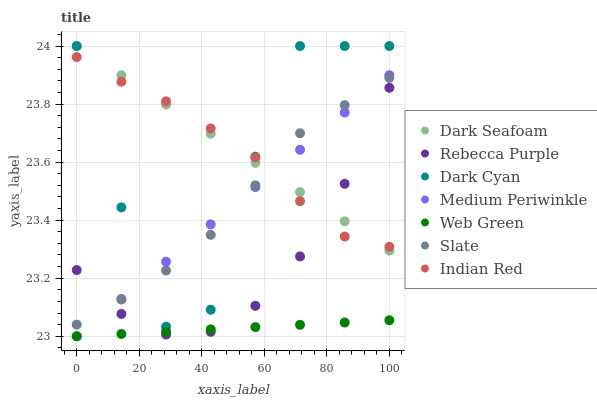Does Web Green have the minimum area under the curve?
Answer yes or no. Yes. Does Dark Seafoam have the maximum area under the curve?
Answer yes or no. Yes. Does Medium Periwinkle have the minimum area under the curve?
Answer yes or no. No. Does Medium Periwinkle have the maximum area under the curve?
Answer yes or no. No. Is Dark Seafoam the smoothest?
Answer yes or no. Yes. Is Dark Cyan the roughest?
Answer yes or no. Yes. Is Medium Periwinkle the smoothest?
Answer yes or no. No. Is Medium Periwinkle the roughest?
Answer yes or no. No. Does Medium Periwinkle have the lowest value?
Answer yes or no. Yes. Does Dark Seafoam have the lowest value?
Answer yes or no. No. Does Dark Cyan have the highest value?
Answer yes or no. Yes. Does Medium Periwinkle have the highest value?
Answer yes or no. No. Is Rebecca Purple less than Dark Cyan?
Answer yes or no. Yes. Is Dark Seafoam greater than Web Green?
Answer yes or no. Yes. Does Dark Cyan intersect Medium Periwinkle?
Answer yes or no. Yes. Is Dark Cyan less than Medium Periwinkle?
Answer yes or no. No. Is Dark Cyan greater than Medium Periwinkle?
Answer yes or no. No. Does Rebecca Purple intersect Dark Cyan?
Answer yes or no. No. 